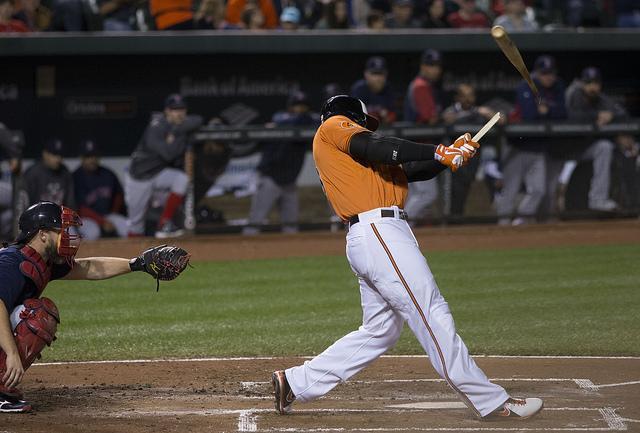How many people are visible?
Give a very brief answer. 11. How many giraffes are in this scene?
Give a very brief answer. 0. 